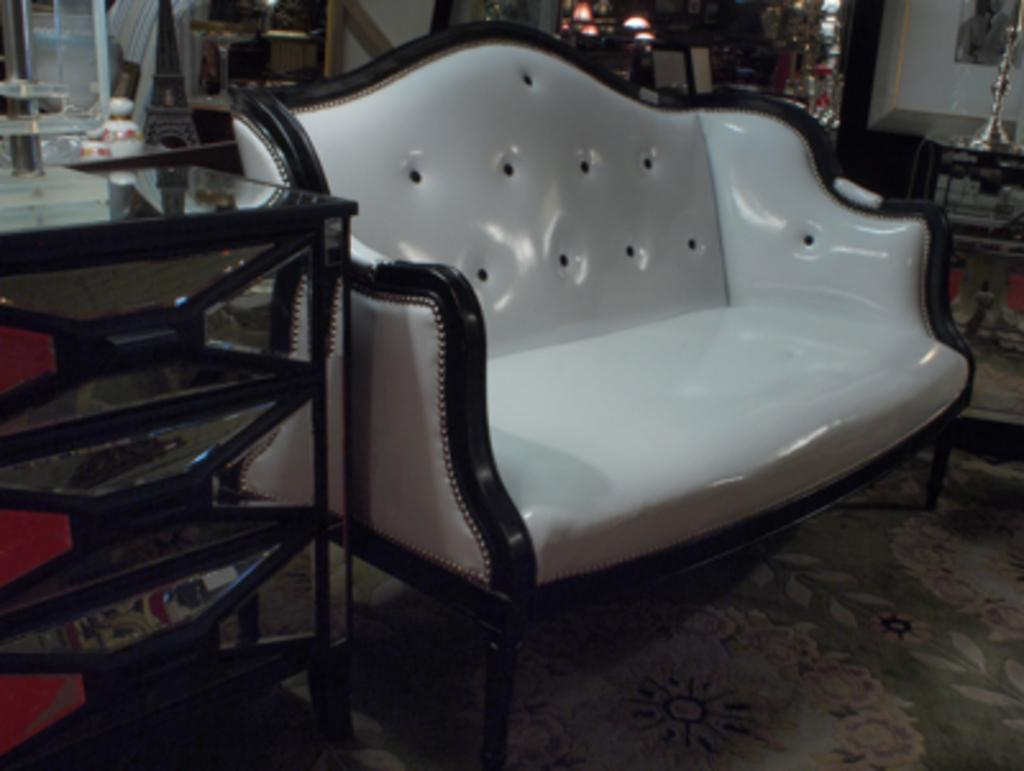What type of furniture is on the floor in the image? There is a sofa on the floor in the image. What other piece of furniture is near the sofa? There is a table beside the sofa in the image. In which room was the image taken? The image was taken in a living room. How many copies of the birthday sack can be seen in the image? There is no mention of a birthday sack in the image, so it cannot be determined how many copies are present. 